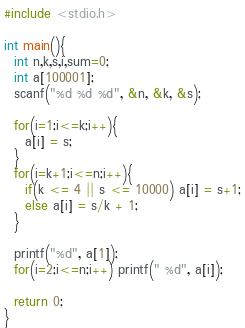Convert code to text. <code><loc_0><loc_0><loc_500><loc_500><_C_>#include <stdio.h>

int main(){
  int n,k,s,i,sum=0;
  int a[100001];
  scanf("%d %d %d", &n, &k, &s);
  
  for(i=1;i<=k;i++){
    a[i] = s;
  }
  for(i=k+1;i<=n;i++){
    if(k <= 4 || s <= 10000) a[i] = s+1;
    else a[i] = s/k + 1;
  }
  
  printf("%d", a[1]);
  for(i=2;i<=n;i++) printf(" %d", a[i]);
  
  return 0;
}</code> 